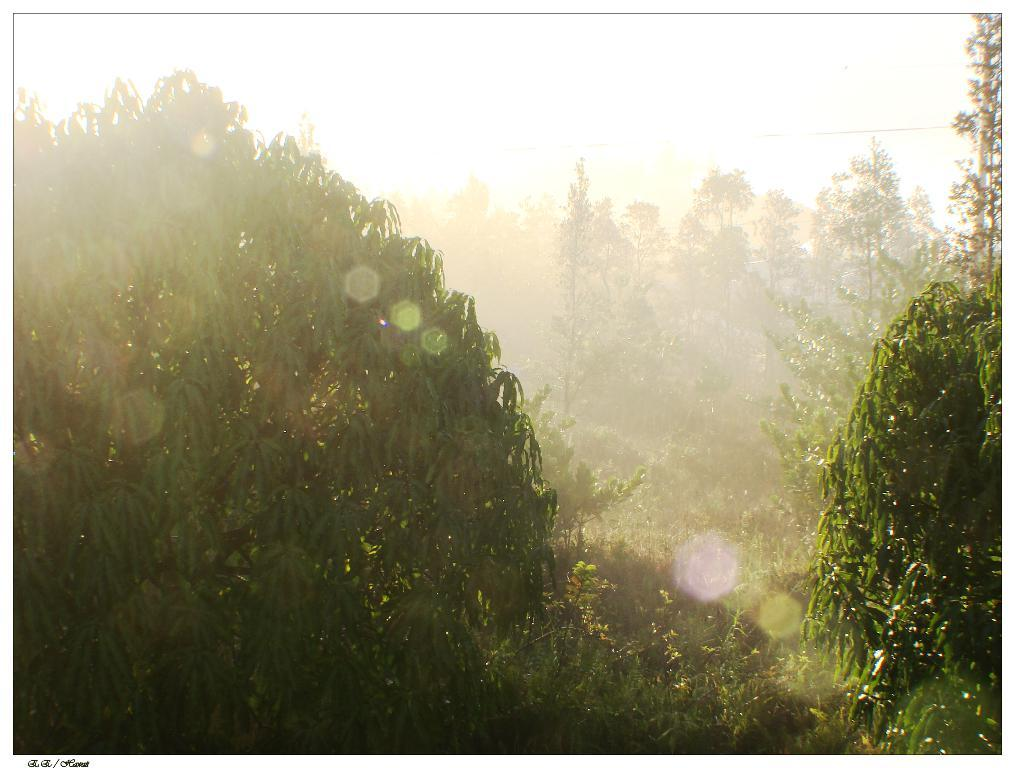What type of vegetation can be seen in the image? There are trees in the image. What level of difficulty is the mine in the image designed for? There is no mine present in the image; it only features trees. Can you see a cat playing among the trees in the image? There is no cat present in the image; it only features trees. 